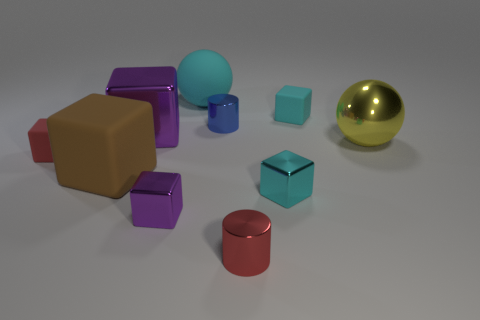There is a tiny cyan matte thing that is behind the large metal block; what shape is it?
Your response must be concise. Cube. There is a tiny metal cylinder that is behind the small red matte object left of the small blue object; what number of metal objects are in front of it?
Keep it short and to the point. 5. There is a metal cylinder left of the red metal object; is its color the same as the shiny sphere?
Give a very brief answer. No. How many other objects are the same shape as the cyan metal object?
Make the answer very short. 5. What number of other objects are there of the same material as the tiny red cylinder?
Your answer should be very brief. 5. What material is the tiny block behind the big yellow sphere that is right of the cyan block in front of the big yellow ball made of?
Make the answer very short. Rubber. Are the large yellow ball and the blue cylinder made of the same material?
Make the answer very short. Yes. How many cubes are either tiny metal things or purple metal things?
Offer a terse response. 3. There is a cylinder right of the small blue metallic object; what is its color?
Offer a terse response. Red. What number of metal objects are either big cyan objects or small cylinders?
Ensure brevity in your answer.  2. 